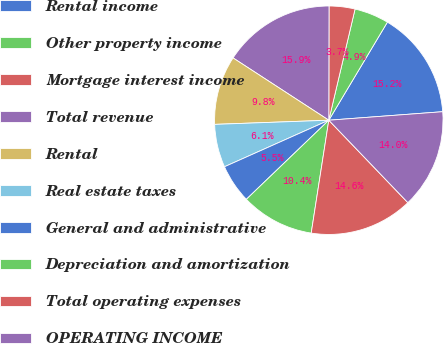<chart> <loc_0><loc_0><loc_500><loc_500><pie_chart><fcel>Rental income<fcel>Other property income<fcel>Mortgage interest income<fcel>Total revenue<fcel>Rental<fcel>Real estate taxes<fcel>General and administrative<fcel>Depreciation and amortization<fcel>Total operating expenses<fcel>OPERATING INCOME<nl><fcel>15.24%<fcel>4.88%<fcel>3.66%<fcel>15.85%<fcel>9.76%<fcel>6.1%<fcel>5.49%<fcel>10.37%<fcel>14.63%<fcel>14.02%<nl></chart> 